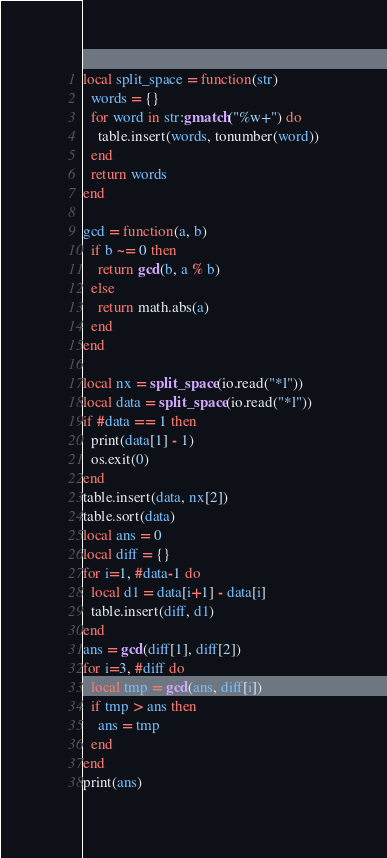<code> <loc_0><loc_0><loc_500><loc_500><_Lua_>local split_space = function(str)
  words = {}
  for word in str:gmatch("%w+") do
    table.insert(words, tonumber(word))
  end
  return words
end

gcd = function(a, b)
  if b ~= 0 then
    return gcd(b, a % b)
  else
    return math.abs(a)
  end
end

local nx = split_space(io.read("*l"))
local data = split_space(io.read("*l"))
if #data == 1 then
  print(data[1] - 1)
  os.exit(0)
end
table.insert(data, nx[2])
table.sort(data)
local ans = 0
local diff = {}
for i=1, #data-1 do
  local d1 = data[i+1] - data[i]
  table.insert(diff, d1)
end
ans = gcd(diff[1], diff[2])
for i=3, #diff do
  local tmp = gcd(ans, diff[i])
  if tmp > ans then
    ans = tmp
  end
end
print(ans)</code> 